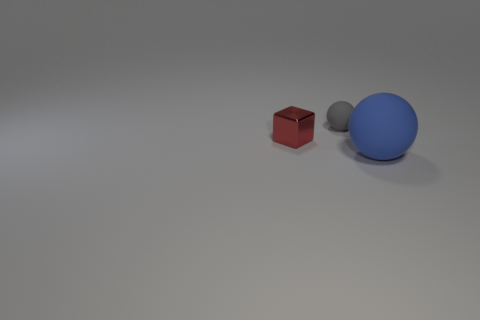Add 1 big gray metallic balls. How many objects exist? 4 Subtract all blocks. How many objects are left? 2 Subtract 0 green cubes. How many objects are left? 3 Subtract all big matte things. Subtract all large objects. How many objects are left? 1 Add 1 gray spheres. How many gray spheres are left? 2 Add 1 large things. How many large things exist? 2 